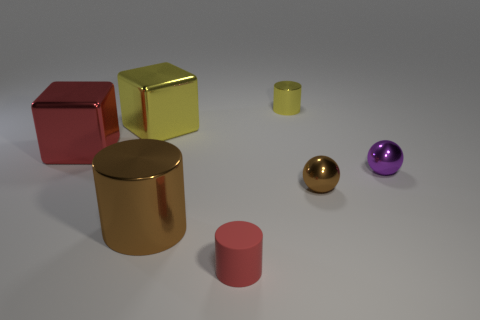Is there another tiny object that has the same shape as the purple shiny thing?
Your answer should be very brief. Yes. Are there fewer metallic cubes behind the big red object than metallic objects on the right side of the yellow block?
Your response must be concise. Yes. What is the color of the tiny matte thing?
Your answer should be very brief. Red. There is a brown object to the right of the matte thing; are there any red things in front of it?
Offer a terse response. Yes. How many purple spheres have the same size as the brown ball?
Keep it short and to the point. 1. What number of large yellow objects are behind the thing that is in front of the shiny cylinder that is on the left side of the small yellow cylinder?
Make the answer very short. 1. How many shiny things are behind the small brown thing and right of the small red cylinder?
Your response must be concise. 2. How many matte objects are purple things or red cylinders?
Your response must be concise. 1. What is the small cylinder that is in front of the yellow thing right of the brown metal cylinder on the left side of the tiny red matte object made of?
Provide a succinct answer. Rubber. There is a red object in front of the metal cylinder in front of the small purple object; what is its material?
Ensure brevity in your answer.  Rubber. 